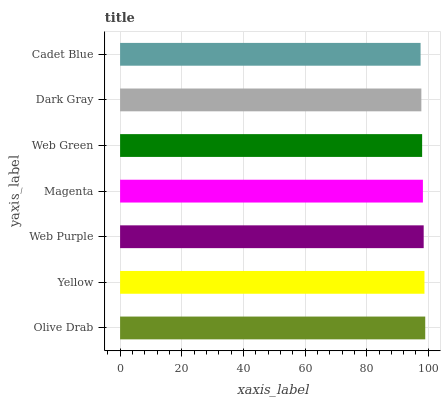Is Cadet Blue the minimum?
Answer yes or no. Yes. Is Olive Drab the maximum?
Answer yes or no. Yes. Is Yellow the minimum?
Answer yes or no. No. Is Yellow the maximum?
Answer yes or no. No. Is Olive Drab greater than Yellow?
Answer yes or no. Yes. Is Yellow less than Olive Drab?
Answer yes or no. Yes. Is Yellow greater than Olive Drab?
Answer yes or no. No. Is Olive Drab less than Yellow?
Answer yes or no. No. Is Magenta the high median?
Answer yes or no. Yes. Is Magenta the low median?
Answer yes or no. Yes. Is Yellow the high median?
Answer yes or no. No. Is Yellow the low median?
Answer yes or no. No. 